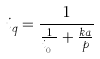<formula> <loc_0><loc_0><loc_500><loc_500>i _ { q } = \frac { 1 } { \frac { 1 } { i _ { q _ { 0 } } } + \frac { k a } { p } }</formula> 